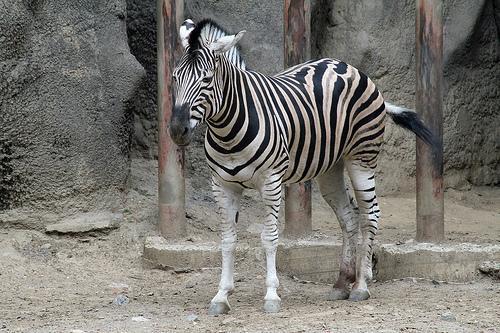How many animals are in this photo?
Give a very brief answer. 1. How many poles are behind the zebra?
Give a very brief answer. 3. 